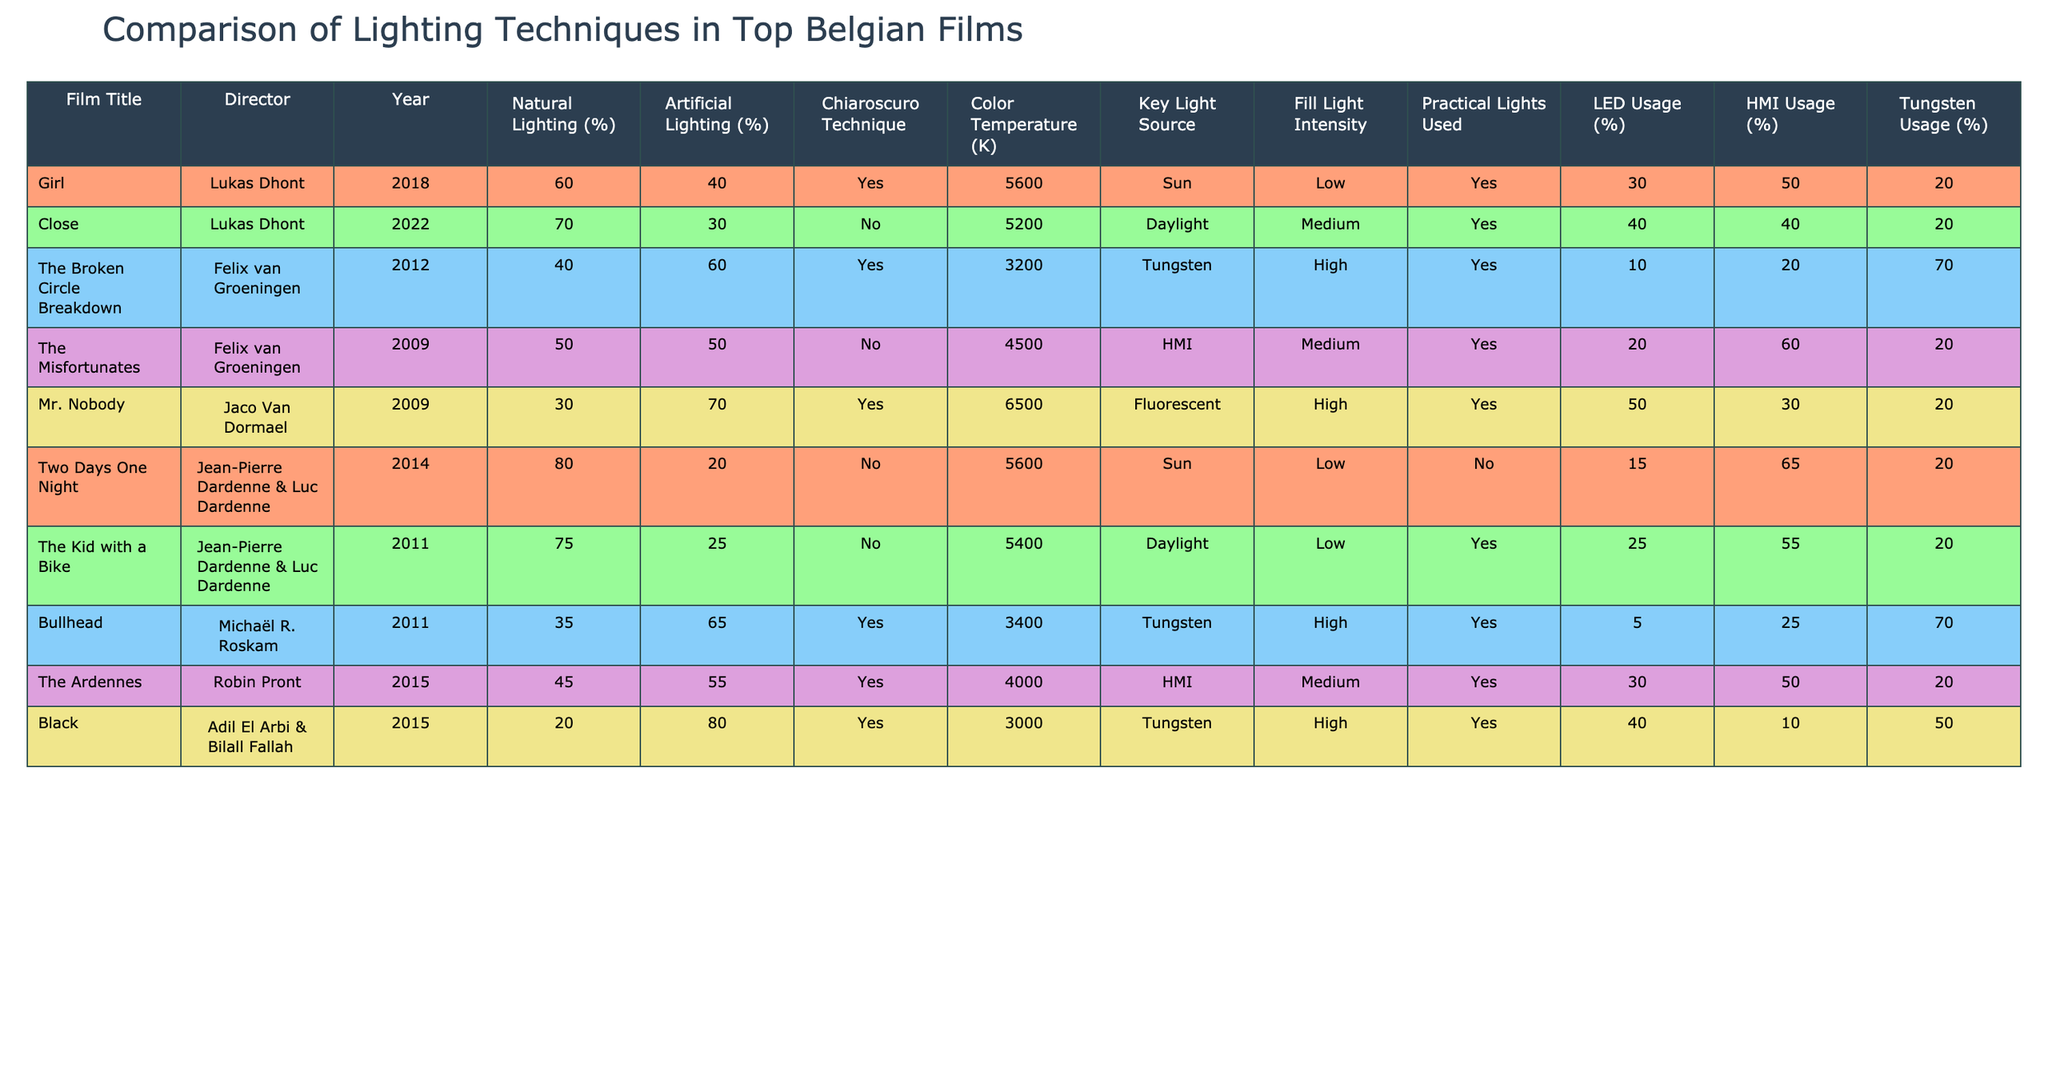What is the film with the highest percentage of natural lighting? The data shows that "Two Days One Night" has 80% natural lighting, which is the highest percentage among the films listed.
Answer: Two Days One Night Which film uses the most artificial lighting? "Black" has 80% artificial lighting, which is the highest value for artificial lighting in the table.
Answer: Black How many films apply the Chiaroscuro technique? By inspecting the table, four films: "Girl," "The Broken Circle Breakdown," "Bullhead," and "Black" use the Chiaroscuro technique.
Answer: Four What is the average color temperature of all films listed? To find the average, sum the color temperatures (5600 + 5200 + 3200 + 4500 + 6500 + 5600 + 5400 + 3400 + 4000 + 3000) and divide by the number of films (10). The total is  41200, thus the average is 41200/10 = 4120K.
Answer: 4120K Which film has the lowest key light source temperature? "Black" has the lowest key light source temperature at 3000K, indicating the use of tungsten lighting.
Answer: Black What percentage of LED usage is reported for "Mr. Nobody"? "Mr. Nobody" uses LEDs at a percentage of 50%, specifically noted in the usage column for LEDs.
Answer: 50% Which technique is commonly used in films that utilize a high fill light intensity? The common technique among those that use a high fill light intensity is Chiaroscuro, noted in "The Broken Circle Breakdown," "Mr. Nobody," and "Bullhead."
Answer: Chiaroscuro Which film combination has the highest combined usage of artificial lighting and Tungsten usage? The calculations reveal that "The Broken Circle Breakdown" and "Black" both have high artificial lighting percentages alongside their Tungsten usage, with "Black" reaching 80% artificial and 50% Tungsten. Combined, that's 130%.
Answer: 130% Which director has created the most films listed in the table? Lukas Dhont, with 2 films "Girl" and "Close," is noted, while others like Felix van Groeningen and Jean-Pierre & Luc Dardenne also have 2 each. However, Lukas Dhont is the only one with more recent contributions.
Answer: Lukas Dhont What's the relationship between practical lights used and natural lighting in the films? Most films listed that utilize practical lights also use a significant percentage of natural lighting, suggesting that these elements may be integrated for a realistic effect in cinematography.
Answer: Integrated What is the median color temperature among the films? By arranging the color temperatures (3000, 3200, 3400, 4000, 4500, 5200, 5400, 5600, 5600, 6500) in ascending order, the median of the two middle values (4500 and 5200) is calculated as (4500 + 5200)/2 = 4850K.
Answer: 4850K 